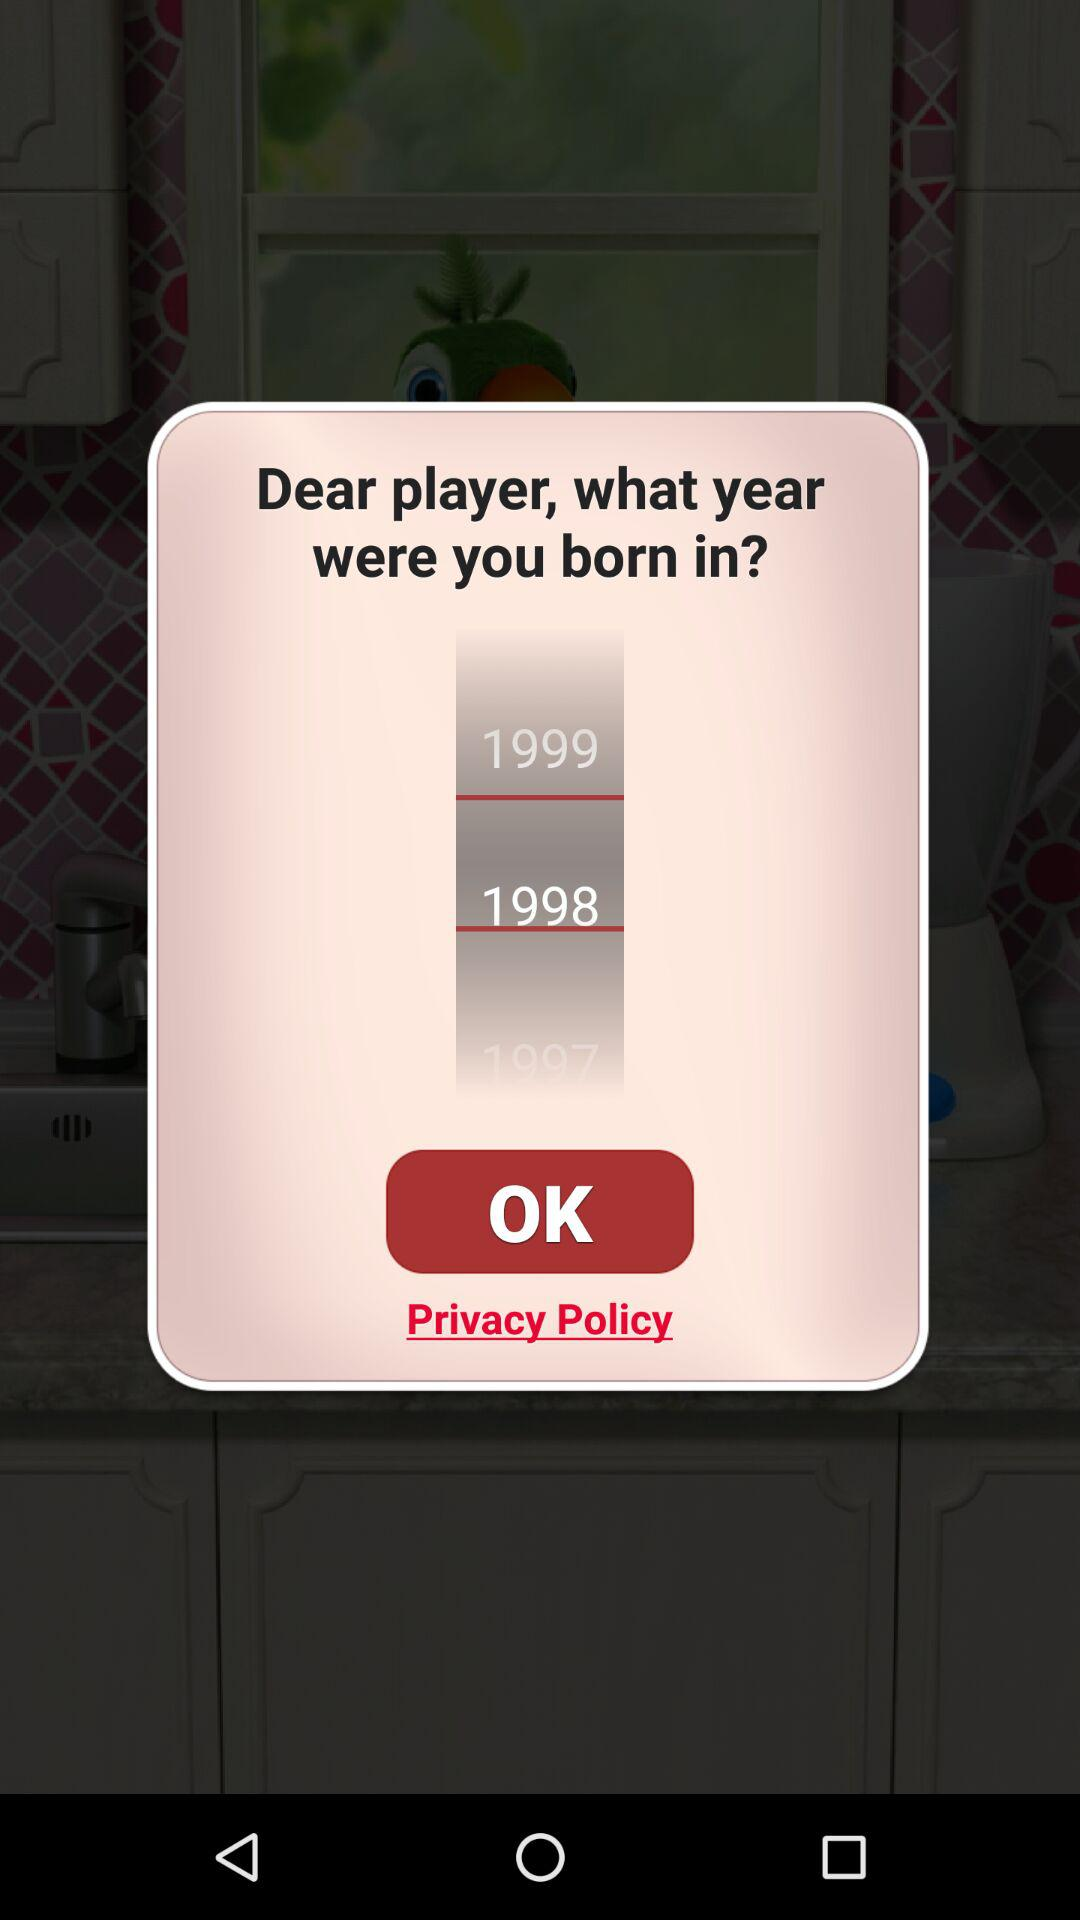In which year was the player born? The player was born in 1998. 